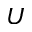Convert formula to latex. <formula><loc_0><loc_0><loc_500><loc_500>U</formula> 